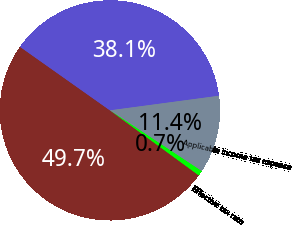Convert chart to OTSL. <chart><loc_0><loc_0><loc_500><loc_500><pie_chart><fcel>For the years ended December<fcel>Income (loss) before income<fcel>Applicable income tax expense<fcel>Effective tax rate<nl><fcel>49.74%<fcel>38.09%<fcel>11.43%<fcel>0.74%<nl></chart> 